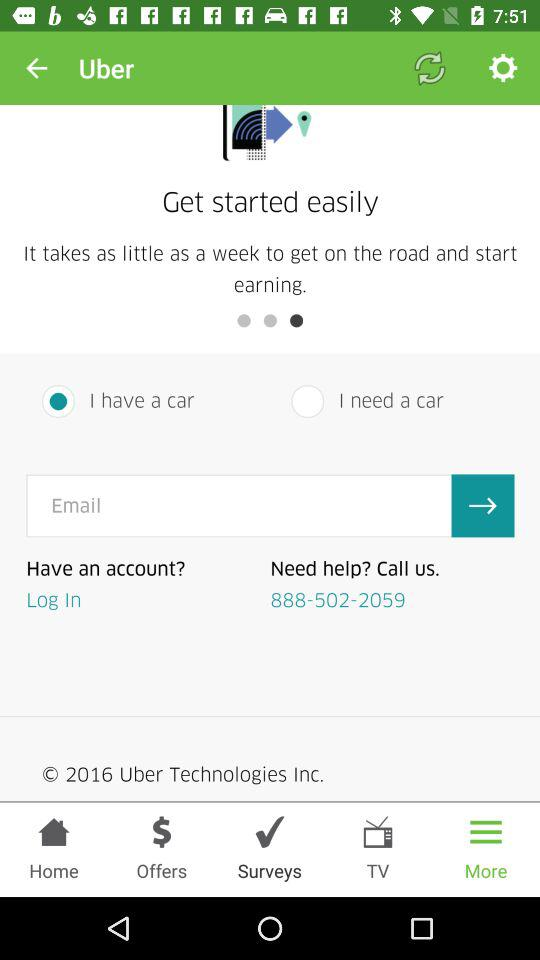What is the contact number? The contact number is 888-502-2059. 